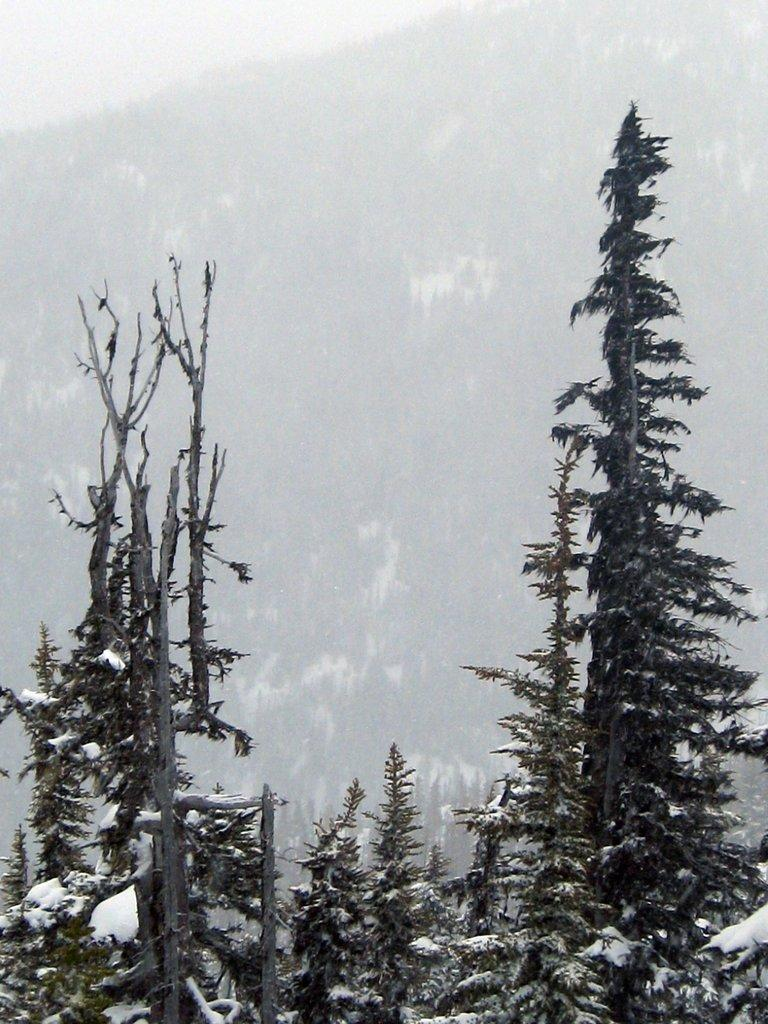What type of vegetation is visible in the image? There are plants and trees in the image. How are the plants and trees in the image affected by the weather? The plants and trees are covered with snow. Can you describe the background of the image? The background of the image is blurry. What type of development can be seen in the image? There is no development or construction visible in the image; it primarily features plants and trees covered in snow. 